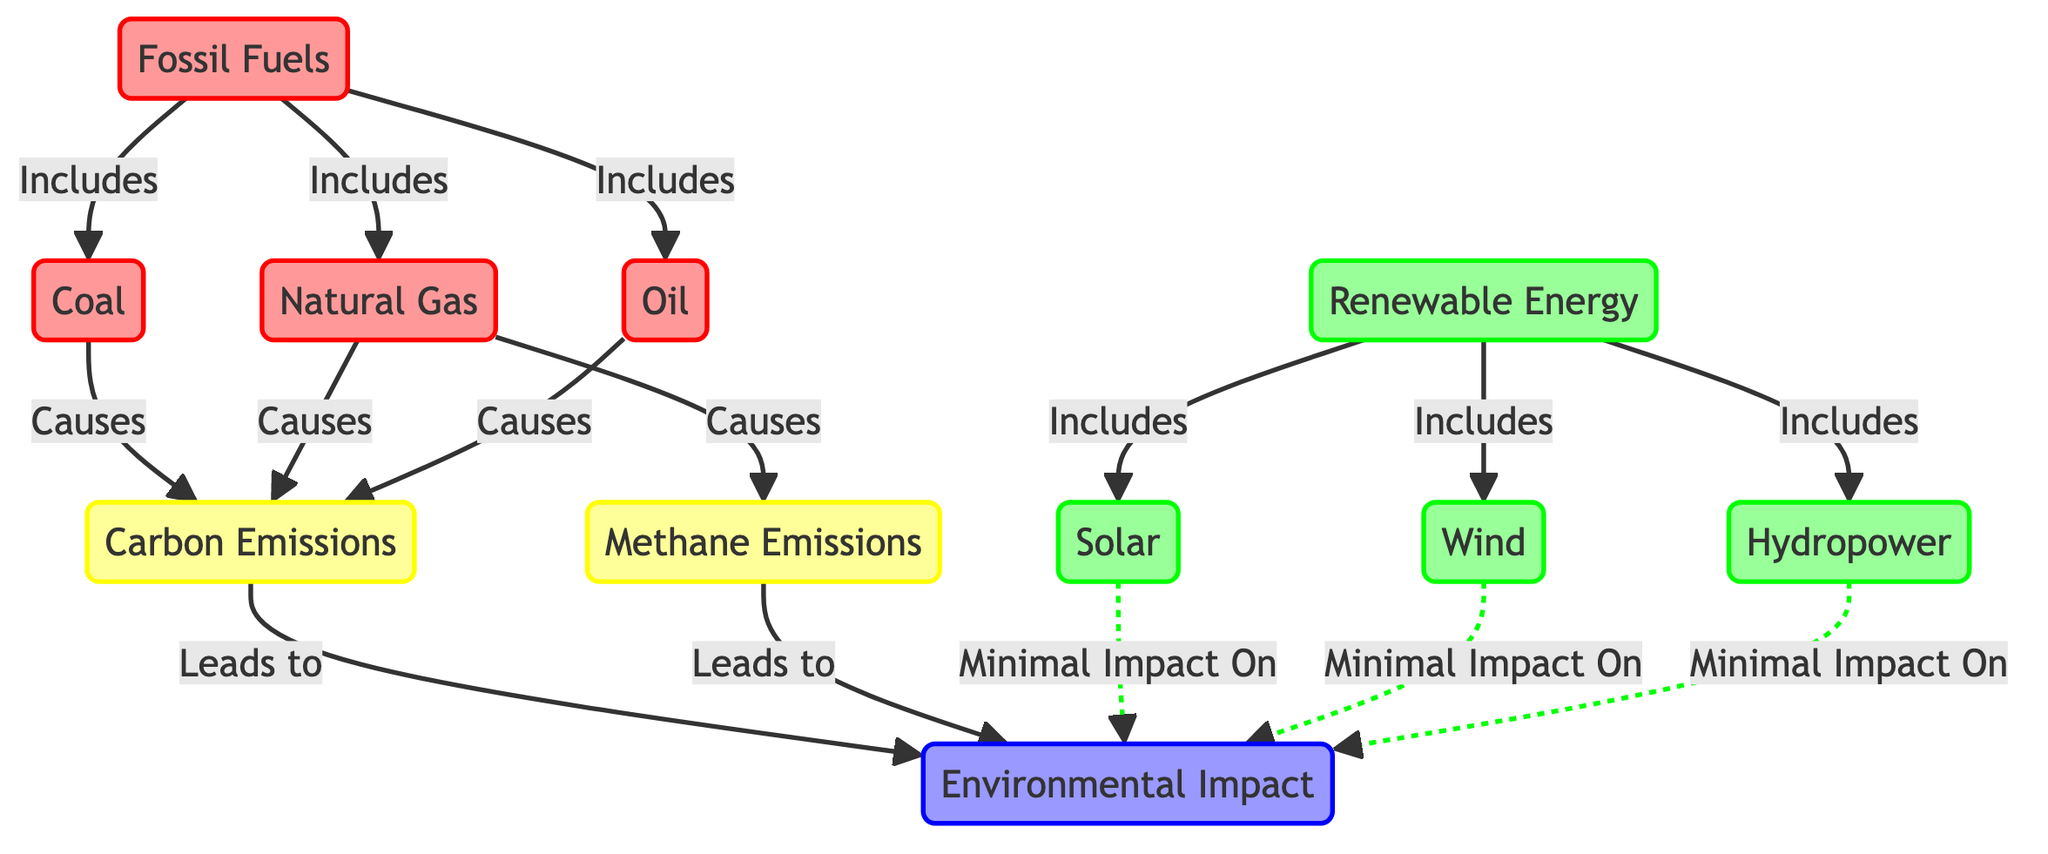What are the fossil fuel sources listed in the diagram? The diagram explicitly lists coal, natural gas, and oil as the fossil fuel sources under the fossil fuels category. Therefore, by identifying the children nodes connected to the fossil fuels node, we can answer this question directly.
Answer: coal, natural gas, oil How many renewable energy sources are represented? The diagram lists three renewable energy sources: solar, wind, and hydropower. Counting these nodes gives a total of three.
Answer: 3 What type of emissions does natural gas cause? According to the diagram, natural gas is shown to cause carbon emissions as well as methane emissions. Thus, the answer encompasses both types of emissions linked by their respective edges to the natural gas node.
Answer: carbon emissions, methane emissions Which renewable energy source has minimal impact on environmental impact? The diagram indicates that solar, wind, and hydropower all have minimal impact on environmental impact as represented by the dotted lines connecting them to the environmental impact node. Therefore, any of these can be correct answers.
Answer: solar, wind, hydropower Which energy source leads to the highest environmental impact? The diagram shows that fossil fuels, specifically through coal, natural gas, and oil, lead to carbon emissions and methane emissions, which in turn lead to environmental impact. As fossil fuels are given direct connections to carbon and methane emissions, they can be concluded as the sources with the highest environmental impact.
Answer: fossil fuels What color represents fossil fuels in the diagram? The diagram uses a red color scheme (fill: #FF9999) for fossil fuels, which is clearly defined in its styling. By referencing the class definitions, it's apparent that this color specifically denotes fossil fuel sources.
Answer: red How are solar and wind energy sources categorized in the diagram? Solar and wind are both categorized under the renewable energy section of the diagram. This can be determined by tracing their connections from the renewable energy node.
Answer: renewable energy What is the relationship between carbon emissions and environmental impact? The diagram explicitly states that carbon emissions lead to environmental impact, forming a clear directional linkage that indicates a cause-and-effect relationship between the two.
Answer: leads to How many types of emissions are identified in the diagram? The diagram indicates two types of emissions: carbon emissions and methane emissions. Counting these nodes associated with emissions provides the total count.
Answer: 2 What does hydropower contribute to environmental impact? The diagram illustrates that hydropower has minimal impact on environmental impact, which is depicted through a dotted line between the hydropower node and the environmental impact node.
Answer: Minimal Impact On 